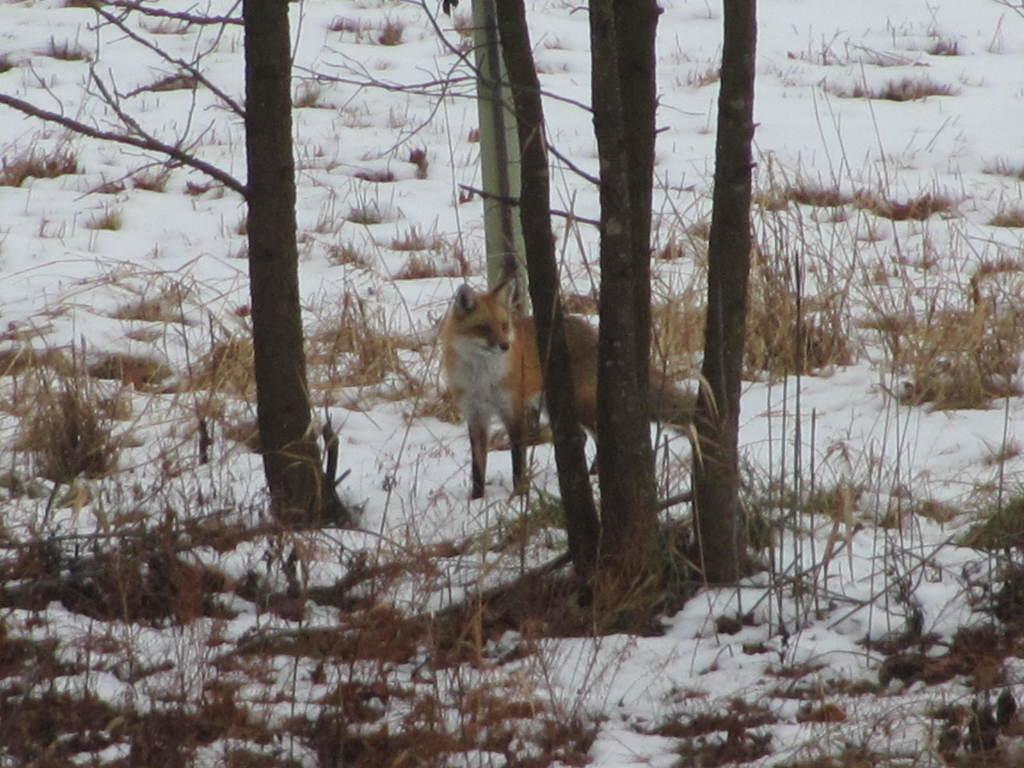Can you describe this image briefly? In the foreground there are plants and grass. In the center of the picture there are trees, grass and a fox. In the picture there is snow everywhere. 